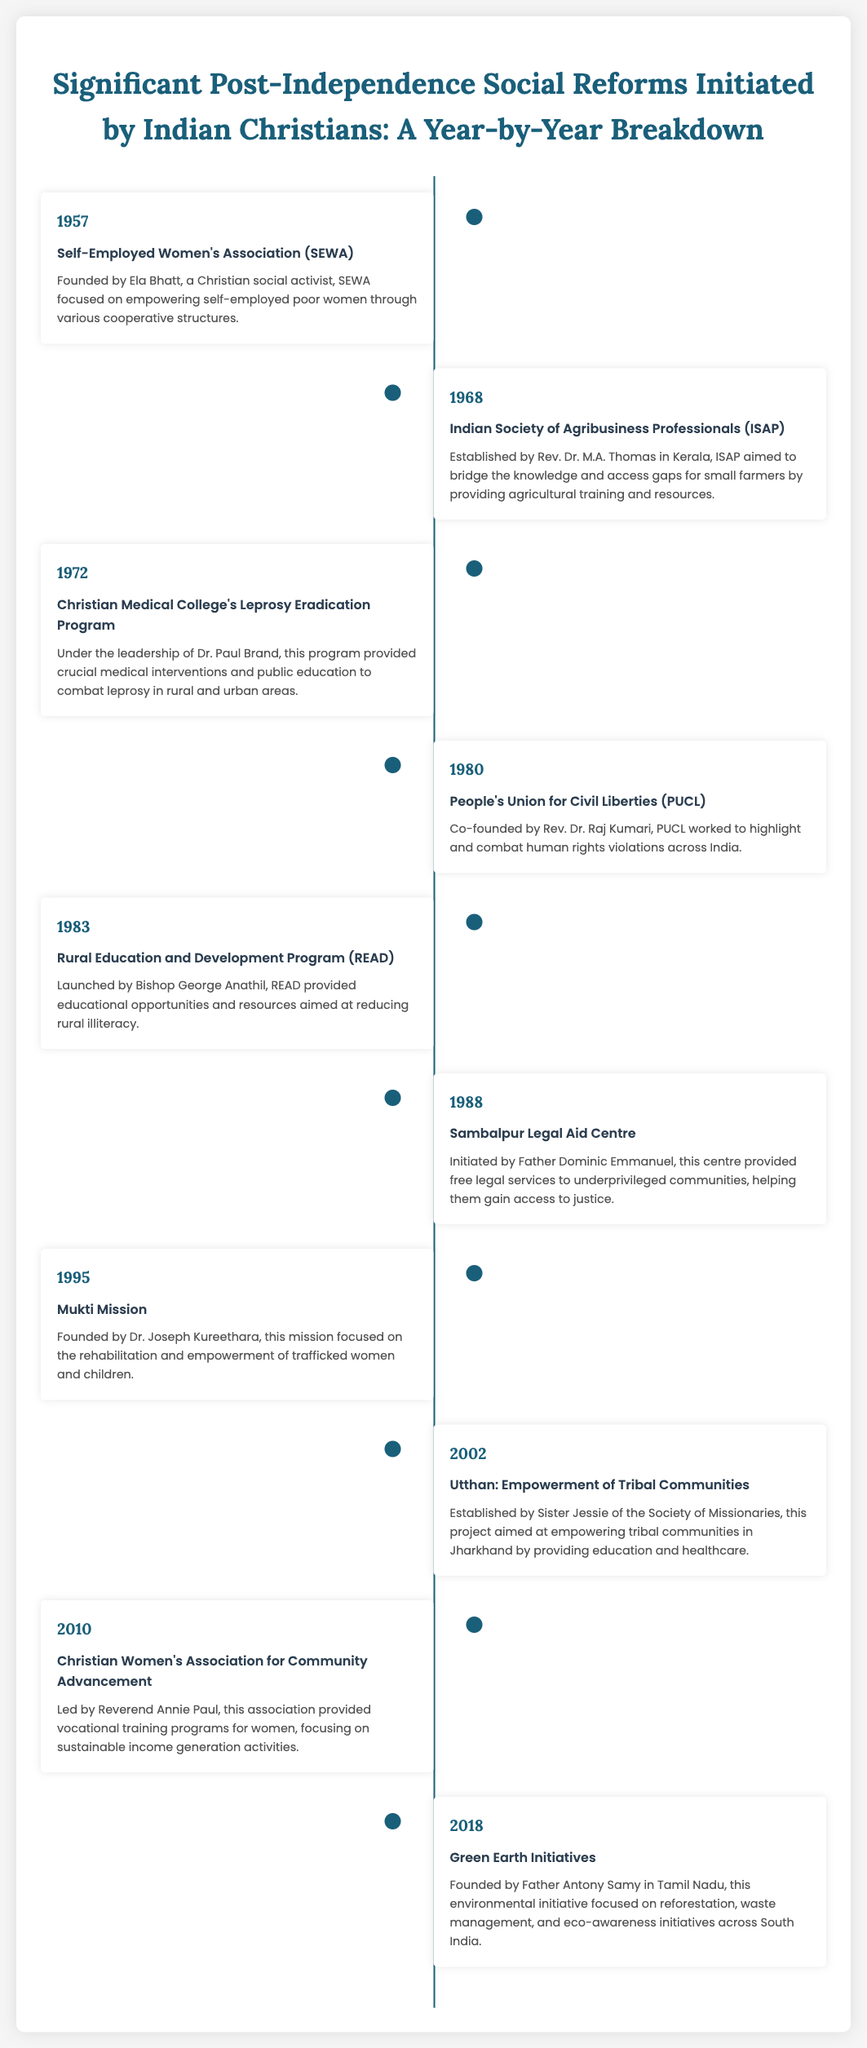what was established in 1957? The event established in 1957 is the Self-Employed Women's Association (SEWA), founded by Ela Bhatt.
Answer: Self-Employed Women's Association (SEWA) who led the Leprosy Eradication Program in 1972? The Leprosy Eradication Program in 1972 was led by Dr. Paul Brand.
Answer: Dr. Paul Brand what year was the People's Union for Civil Liberties co-founded? The People's Union for Civil Liberties was co-founded in 1980.
Answer: 1980 which initiative focused on empowering tribal communities? The initiative that focused on empowering tribal communities is Utthan, established in 2002.
Answer: Utthan who initiated the Sambalpur Legal Aid Centre in 1988? The Sambalpur Legal Aid Centre in 1988 was initiated by Father Dominic Emmanuel.
Answer: Father Dominic Emmanuel what type of program did the Christian Women's Association for Community Advancement provide? The Christian Women's Association for Community Advancement provided vocational training programs.
Answer: vocational training programs which social reform program aimed at reducing rural illiteracy? The program aimed at reducing rural illiteracy is the Rural Education and Development Program (READ) launched in 1983.
Answer: Rural Education and Development Program (READ) how many years span the events listed in this infographic? The events in the infographic span from 1957 to 2018, thus covering a span of 61 years.
Answer: 61 years what color is predominantly used for the timeline in the document? The predominant color used for the timeline in the document is a shade of blue (#1a5f7a).
Answer: blue 